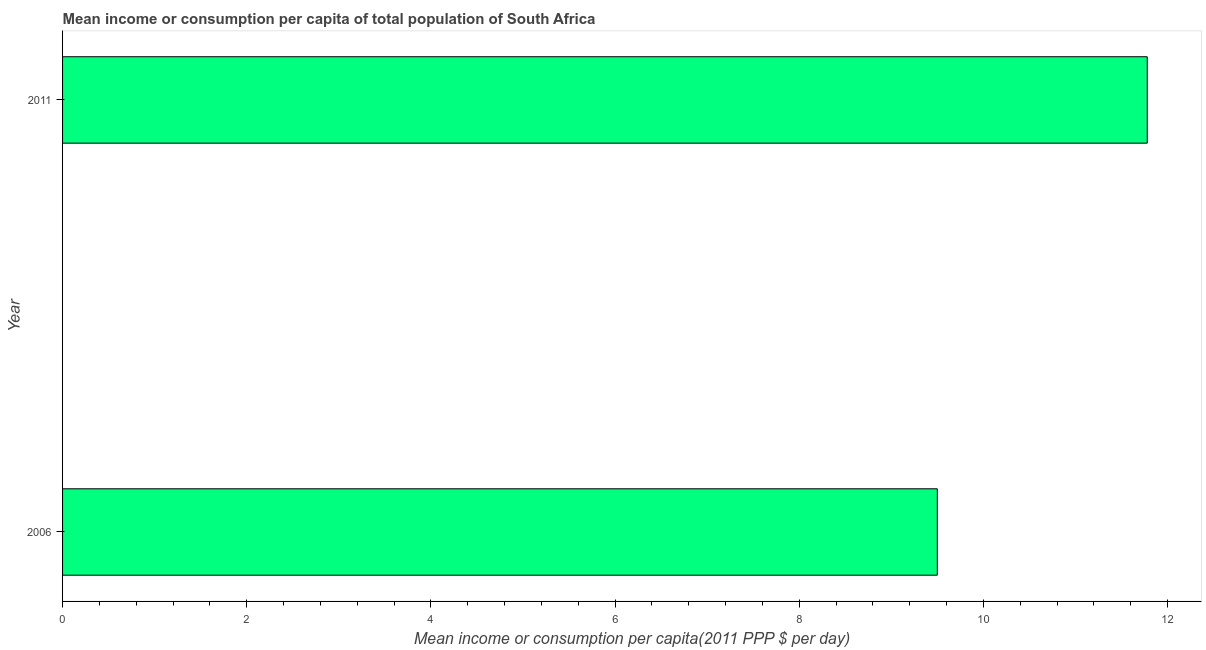Does the graph contain any zero values?
Your answer should be very brief. No. Does the graph contain grids?
Your answer should be very brief. No. What is the title of the graph?
Provide a short and direct response. Mean income or consumption per capita of total population of South Africa. What is the label or title of the X-axis?
Ensure brevity in your answer.  Mean income or consumption per capita(2011 PPP $ per day). What is the mean income or consumption in 2011?
Keep it short and to the point. 11.78. Across all years, what is the maximum mean income or consumption?
Your answer should be compact. 11.78. Across all years, what is the minimum mean income or consumption?
Offer a terse response. 9.5. What is the sum of the mean income or consumption?
Make the answer very short. 21.28. What is the difference between the mean income or consumption in 2006 and 2011?
Your answer should be very brief. -2.28. What is the average mean income or consumption per year?
Offer a very short reply. 10.64. What is the median mean income or consumption?
Ensure brevity in your answer.  10.64. What is the ratio of the mean income or consumption in 2006 to that in 2011?
Give a very brief answer. 0.81. Is the mean income or consumption in 2006 less than that in 2011?
Provide a succinct answer. Yes. Are all the bars in the graph horizontal?
Ensure brevity in your answer.  Yes. How many years are there in the graph?
Offer a terse response. 2. What is the difference between two consecutive major ticks on the X-axis?
Give a very brief answer. 2. What is the Mean income or consumption per capita(2011 PPP $ per day) of 2006?
Offer a very short reply. 9.5. What is the Mean income or consumption per capita(2011 PPP $ per day) in 2011?
Make the answer very short. 11.78. What is the difference between the Mean income or consumption per capita(2011 PPP $ per day) in 2006 and 2011?
Keep it short and to the point. -2.28. What is the ratio of the Mean income or consumption per capita(2011 PPP $ per day) in 2006 to that in 2011?
Offer a very short reply. 0.81. 